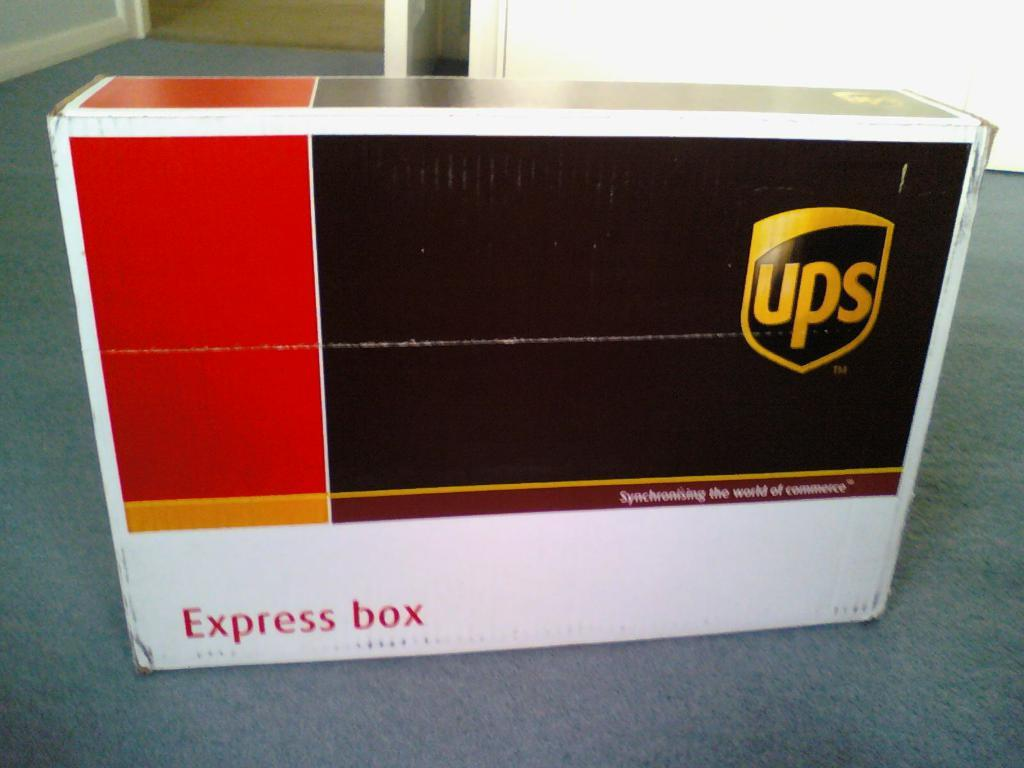<image>
Provide a brief description of the given image. A white, red, and brown Express box is from ups. 